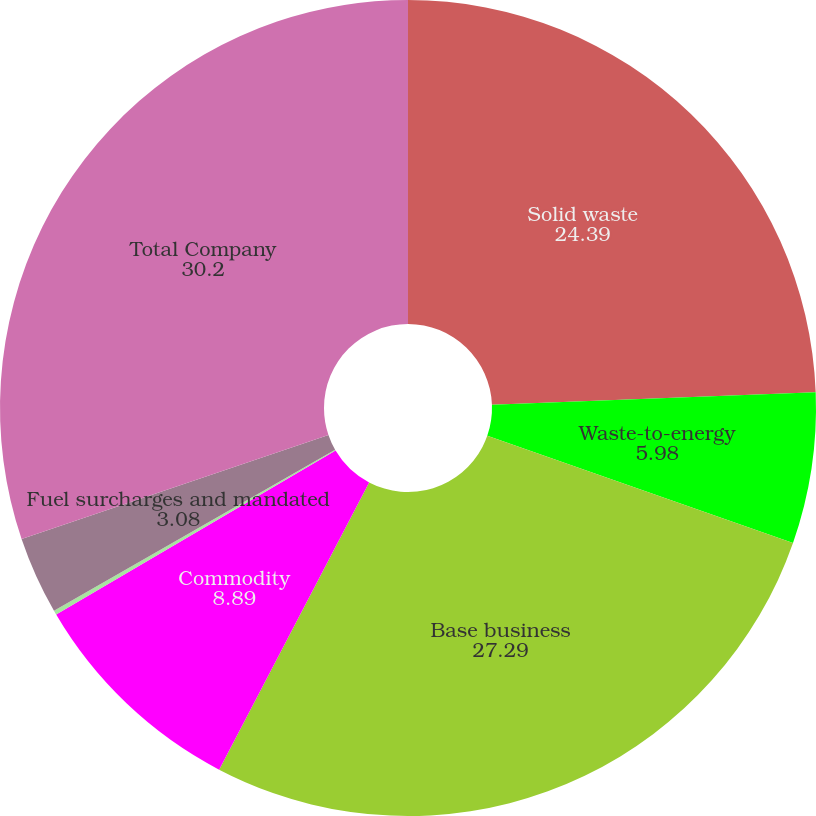<chart> <loc_0><loc_0><loc_500><loc_500><pie_chart><fcel>Solid waste<fcel>Waste-to-energy<fcel>Base business<fcel>Commodity<fcel>Electricity (IPPs)<fcel>Fuel surcharges and mandated<fcel>Total Company<nl><fcel>24.39%<fcel>5.98%<fcel>27.29%<fcel>8.89%<fcel>0.17%<fcel>3.08%<fcel>30.2%<nl></chart> 